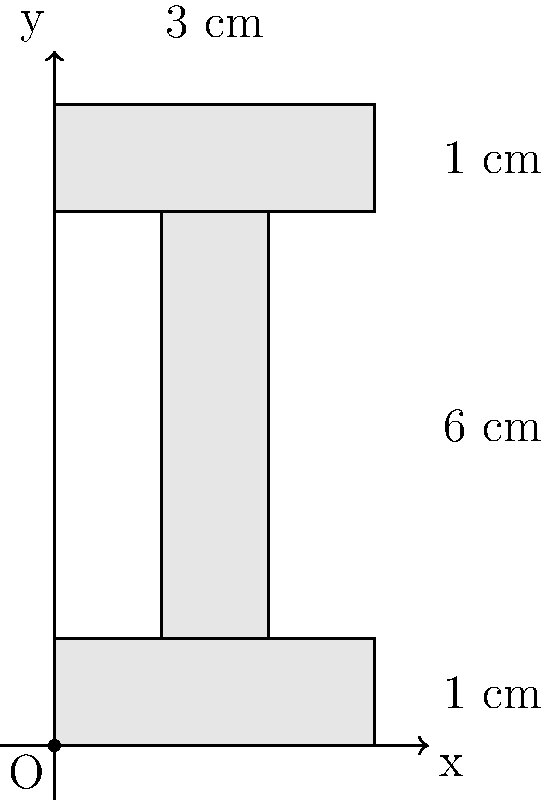Calculate the moment of inertia $I_x$ about the x-axis for the given I-beam cross-section using coordinate geometry. The dimensions are in centimeters, and the origin is at the bottom-left corner of the beam. Assume the density of the material is uniform throughout the cross-section. To calculate the moment of inertia $I_x$ about the x-axis, we'll use the parallel axis theorem and divide the I-beam into three rectangles:

1. Bottom flange: $3 \times 1$ cm
2. Web: $1 \times 4$ cm
3. Top flange: $3 \times 1$ cm

Step 1: Calculate $I_x$ for each rectangle using the formula $I_x = \frac{1}{12}bh^3 + Ad^2$, where $b$ is the base, $h$ is the height, $A$ is the area, and $d$ is the distance from the rectangle's centroid to the x-axis.

Bottom flange:
$I_{x1} = \frac{1}{12}(3)(1)^3 + (3)(1)(0.5)^2 = 0.25 + 0.75 = 1$ cm⁴

Web:
$I_{x2} = \frac{1}{12}(1)(4)^3 + (1)(4)(2)^2 = 5.33 + 16 = 21.33$ cm⁴

Top flange:
$I_{x3} = \frac{1}{12}(3)(1)^3 + (3)(1)(5.5)^2 = 0.25 + 90.75 = 91$ cm⁴

Step 2: Sum up the individual moments of inertia:

$I_x = I_{x1} + I_{x2} + I_{x3} = 1 + 21.33 + 91 = 113.33$ cm⁴

Therefore, the moment of inertia $I_x$ about the x-axis for the given I-beam cross-section is 113.33 cm⁴.
Answer: $113.33$ cm⁴ 